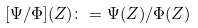<formula> <loc_0><loc_0><loc_500><loc_500>[ \Psi / \Phi ] ( Z ) \colon = \Psi ( Z ) / \Phi ( Z )</formula> 